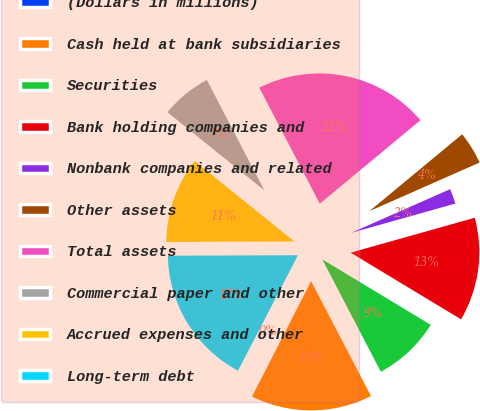Convert chart to OTSL. <chart><loc_0><loc_0><loc_500><loc_500><pie_chart><fcel>(Dollars in millions)<fcel>Cash held at bank subsidiaries<fcel>Securities<fcel>Bank holding companies and<fcel>Nonbank companies and related<fcel>Other assets<fcel>Total assets<fcel>Commercial paper and other<fcel>Accrued expenses and other<fcel>Long-term debt<nl><fcel>0.1%<fcel>15.17%<fcel>8.71%<fcel>13.01%<fcel>2.25%<fcel>4.4%<fcel>21.63%<fcel>6.55%<fcel>10.86%<fcel>17.32%<nl></chart> 